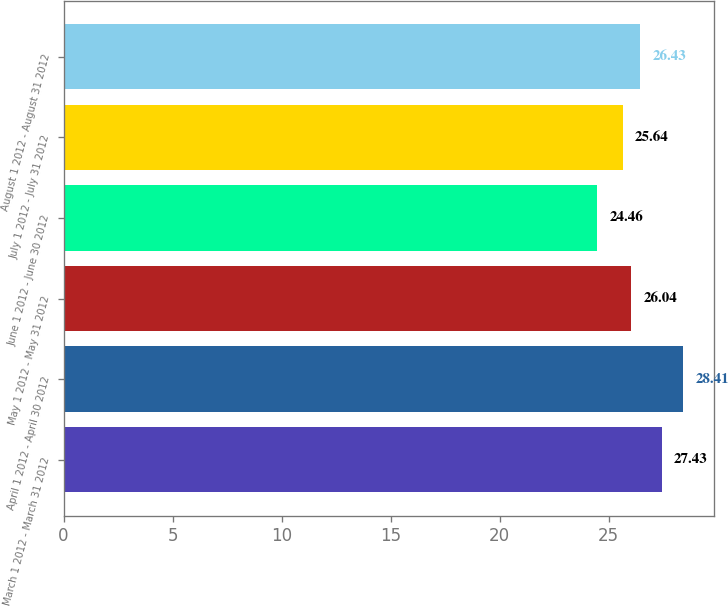Convert chart to OTSL. <chart><loc_0><loc_0><loc_500><loc_500><bar_chart><fcel>March 1 2012 - March 31 2012<fcel>April 1 2012 - April 30 2012<fcel>May 1 2012 - May 31 2012<fcel>June 1 2012 - June 30 2012<fcel>July 1 2012 - July 31 2012<fcel>August 1 2012 - August 31 2012<nl><fcel>27.43<fcel>28.41<fcel>26.04<fcel>24.46<fcel>25.64<fcel>26.43<nl></chart> 